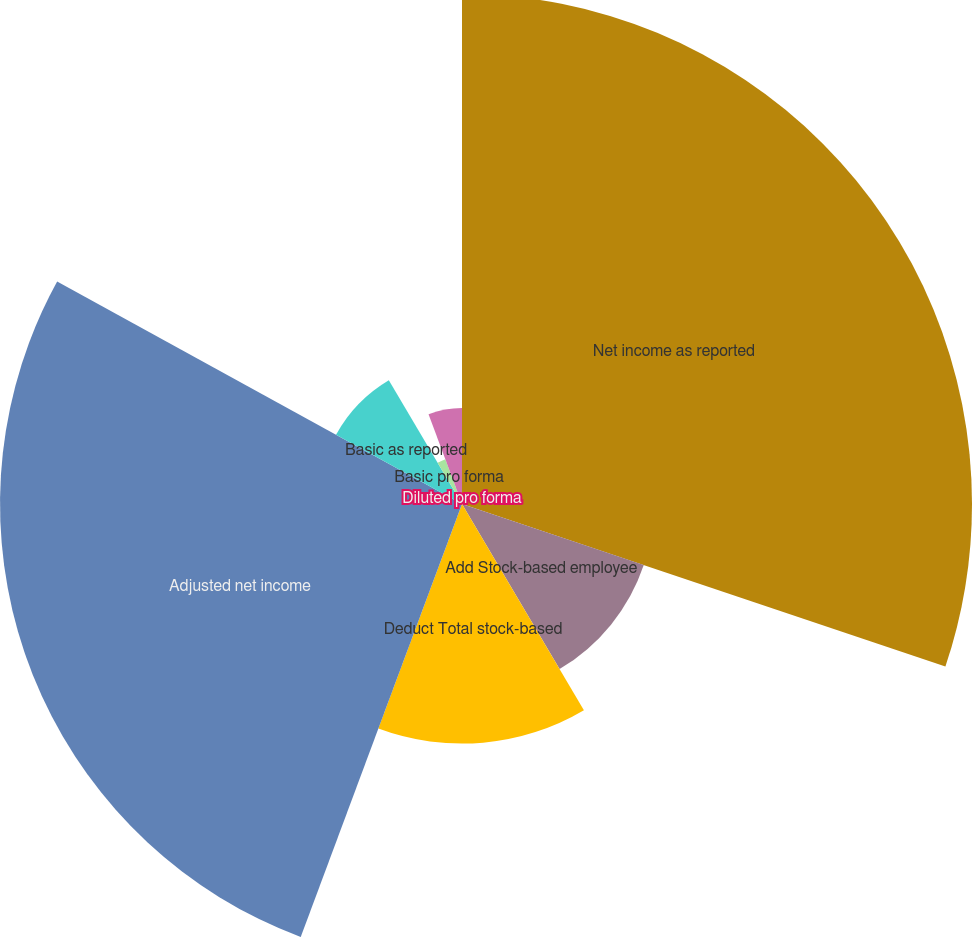Convert chart. <chart><loc_0><loc_0><loc_500><loc_500><pie_chart><fcel>Net income as reported<fcel>Add Stock-based employee<fcel>Deduct Total stock-based<fcel>Adjusted net income<fcel>Basic as reported<fcel>Basic pro forma<fcel>Diluted as reported<fcel>Diluted pro forma<nl><fcel>30.16%<fcel>11.34%<fcel>14.17%<fcel>27.32%<fcel>8.5%<fcel>2.83%<fcel>5.67%<fcel>0.0%<nl></chart> 